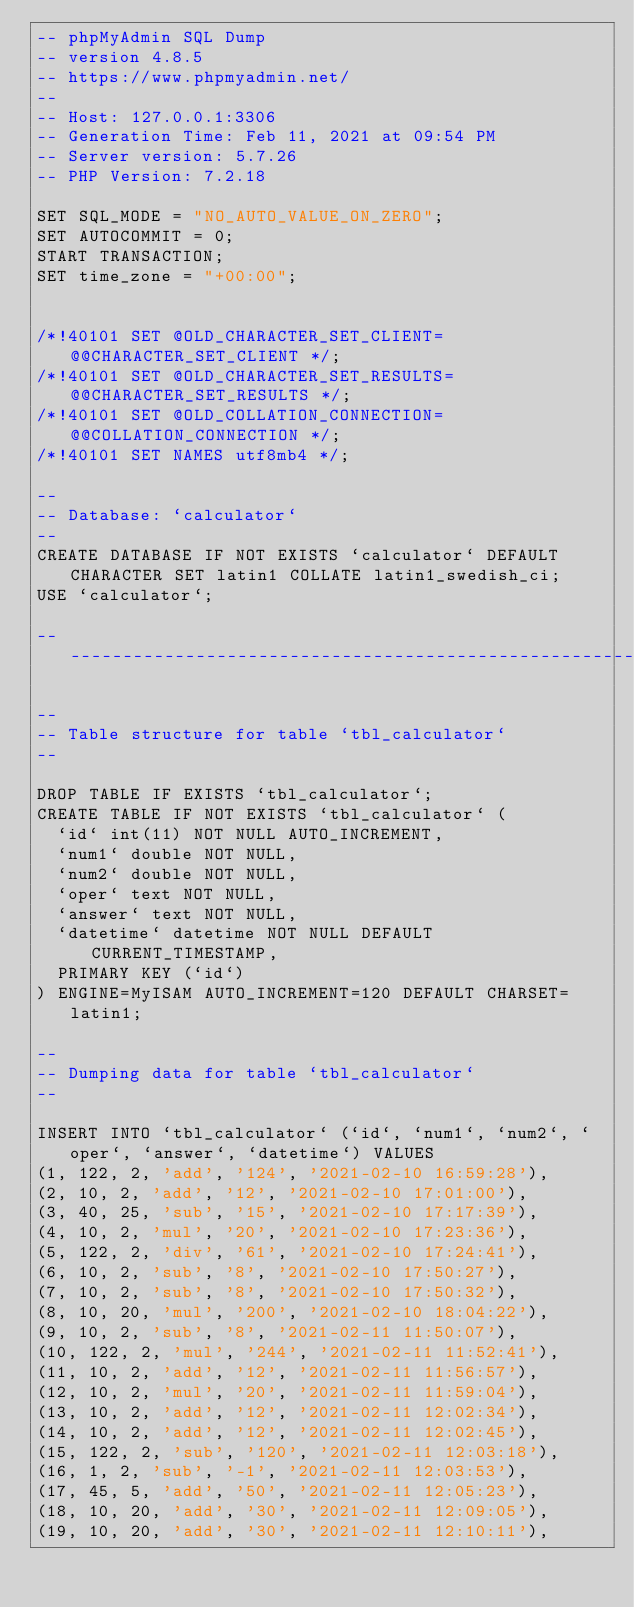Convert code to text. <code><loc_0><loc_0><loc_500><loc_500><_SQL_>-- phpMyAdmin SQL Dump
-- version 4.8.5
-- https://www.phpmyadmin.net/
--
-- Host: 127.0.0.1:3306
-- Generation Time: Feb 11, 2021 at 09:54 PM
-- Server version: 5.7.26
-- PHP Version: 7.2.18

SET SQL_MODE = "NO_AUTO_VALUE_ON_ZERO";
SET AUTOCOMMIT = 0;
START TRANSACTION;
SET time_zone = "+00:00";


/*!40101 SET @OLD_CHARACTER_SET_CLIENT=@@CHARACTER_SET_CLIENT */;
/*!40101 SET @OLD_CHARACTER_SET_RESULTS=@@CHARACTER_SET_RESULTS */;
/*!40101 SET @OLD_COLLATION_CONNECTION=@@COLLATION_CONNECTION */;
/*!40101 SET NAMES utf8mb4 */;

--
-- Database: `calculator`
--
CREATE DATABASE IF NOT EXISTS `calculator` DEFAULT CHARACTER SET latin1 COLLATE latin1_swedish_ci;
USE `calculator`;

-- --------------------------------------------------------

--
-- Table structure for table `tbl_calculator`
--

DROP TABLE IF EXISTS `tbl_calculator`;
CREATE TABLE IF NOT EXISTS `tbl_calculator` (
  `id` int(11) NOT NULL AUTO_INCREMENT,
  `num1` double NOT NULL,
  `num2` double NOT NULL,
  `oper` text NOT NULL,
  `answer` text NOT NULL,
  `datetime` datetime NOT NULL DEFAULT CURRENT_TIMESTAMP,
  PRIMARY KEY (`id`)
) ENGINE=MyISAM AUTO_INCREMENT=120 DEFAULT CHARSET=latin1;

--
-- Dumping data for table `tbl_calculator`
--

INSERT INTO `tbl_calculator` (`id`, `num1`, `num2`, `oper`, `answer`, `datetime`) VALUES
(1, 122, 2, 'add', '124', '2021-02-10 16:59:28'),
(2, 10, 2, 'add', '12', '2021-02-10 17:01:00'),
(3, 40, 25, 'sub', '15', '2021-02-10 17:17:39'),
(4, 10, 2, 'mul', '20', '2021-02-10 17:23:36'),
(5, 122, 2, 'div', '61', '2021-02-10 17:24:41'),
(6, 10, 2, 'sub', '8', '2021-02-10 17:50:27'),
(7, 10, 2, 'sub', '8', '2021-02-10 17:50:32'),
(8, 10, 20, 'mul', '200', '2021-02-10 18:04:22'),
(9, 10, 2, 'sub', '8', '2021-02-11 11:50:07'),
(10, 122, 2, 'mul', '244', '2021-02-11 11:52:41'),
(11, 10, 2, 'add', '12', '2021-02-11 11:56:57'),
(12, 10, 2, 'mul', '20', '2021-02-11 11:59:04'),
(13, 10, 2, 'add', '12', '2021-02-11 12:02:34'),
(14, 10, 2, 'add', '12', '2021-02-11 12:02:45'),
(15, 122, 2, 'sub', '120', '2021-02-11 12:03:18'),
(16, 1, 2, 'sub', '-1', '2021-02-11 12:03:53'),
(17, 45, 5, 'add', '50', '2021-02-11 12:05:23'),
(18, 10, 20, 'add', '30', '2021-02-11 12:09:05'),
(19, 10, 20, 'add', '30', '2021-02-11 12:10:11'),</code> 